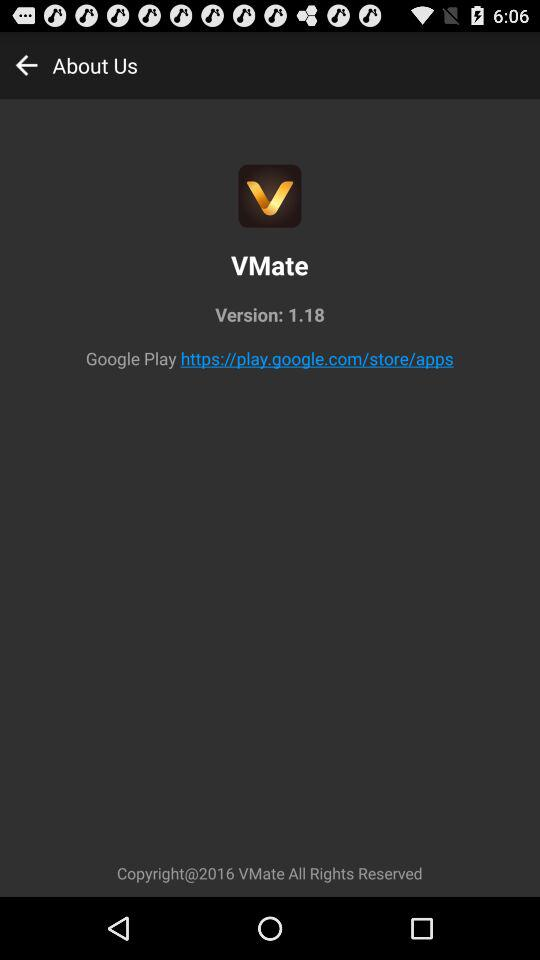What is the "Google Play" URL address? The "Google Play" URL address is https://play.google.com/store/apps. 